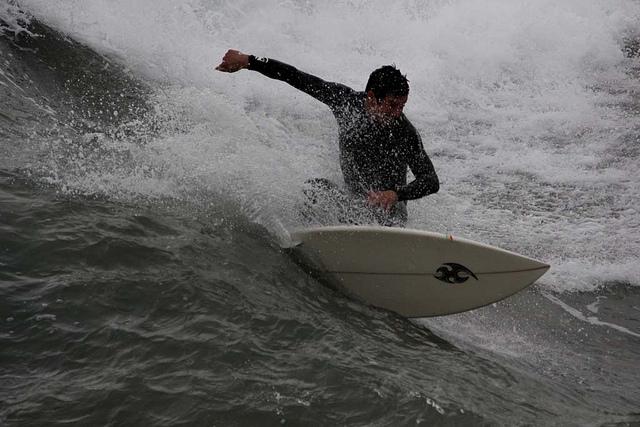Was this picture taken at the beach?
Write a very short answer. Yes. Which arm is raised?
Quick response, please. Right. What is the person riding?
Quick response, please. Surfboard. 